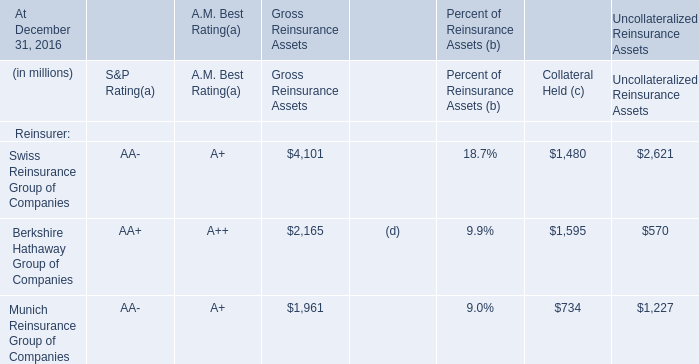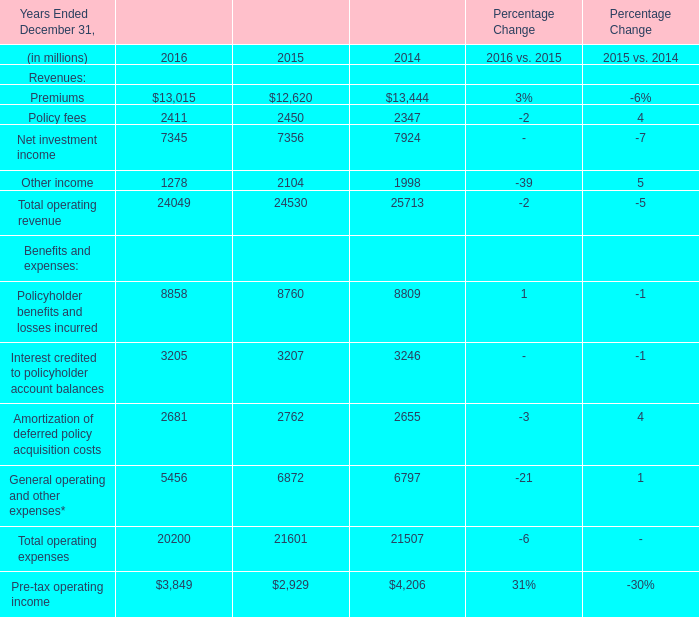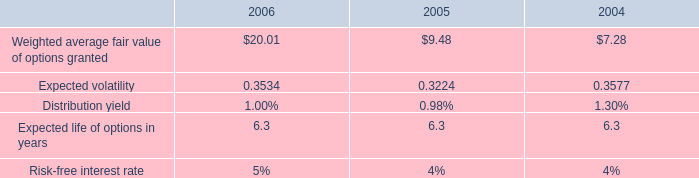What is the average amount of Policy fees of Percentage Change 2014, and Munich Reinsurance Group of Companies of Uncollateralized Reinsurance Assets ? 
Computations: ((2347.0 + 1227.0) / 2)
Answer: 1787.0. 